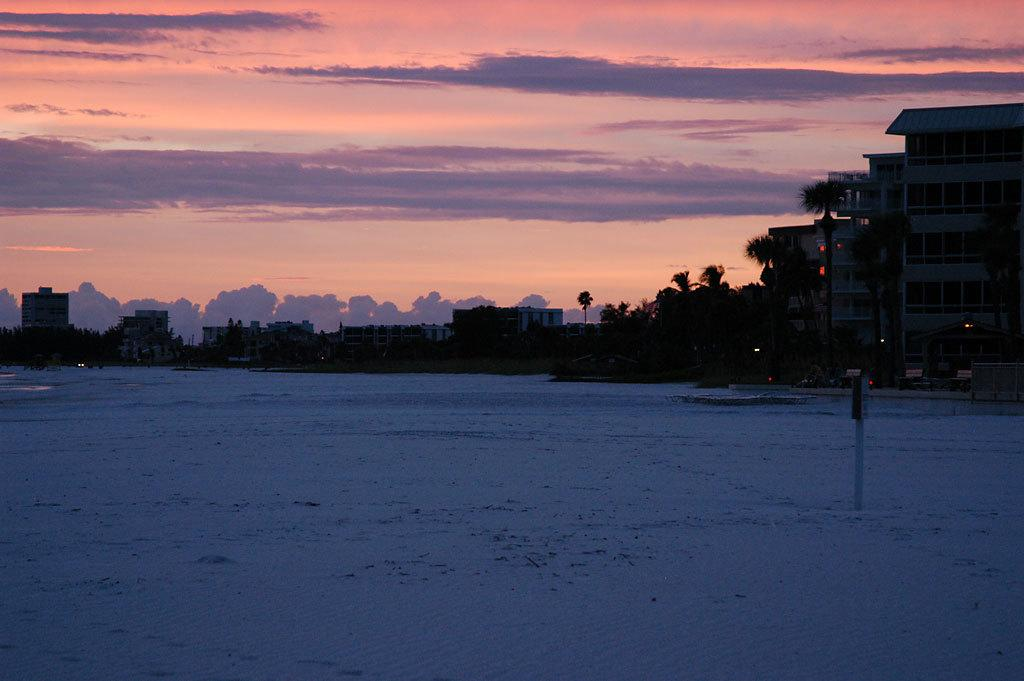Where was the image taken? The image was clicked outside. What can be seen in the middle of the image? There are buildings and trees in the middle of the image. What is visible at the top of the image? The sky is visible at the top of the image. How many dimes are scattered on the ground in the image? There are no dimes present in the image. What type of yarn is being used to decorate the trees in the image? There is no yarn present in the image, and the trees are not being decorated. 